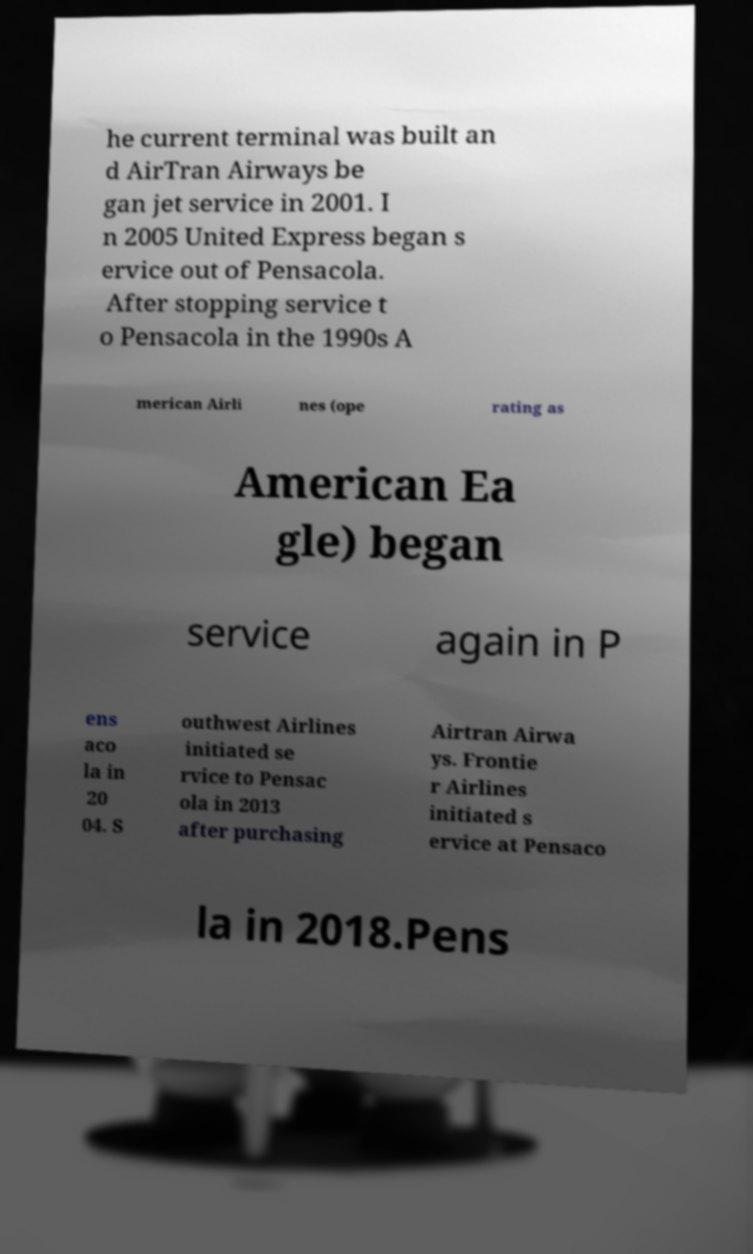There's text embedded in this image that I need extracted. Can you transcribe it verbatim? he current terminal was built an d AirTran Airways be gan jet service in 2001. I n 2005 United Express began s ervice out of Pensacola. After stopping service t o Pensacola in the 1990s A merican Airli nes (ope rating as American Ea gle) began service again in P ens aco la in 20 04. S outhwest Airlines initiated se rvice to Pensac ola in 2013 after purchasing Airtran Airwa ys. Frontie r Airlines initiated s ervice at Pensaco la in 2018.Pens 